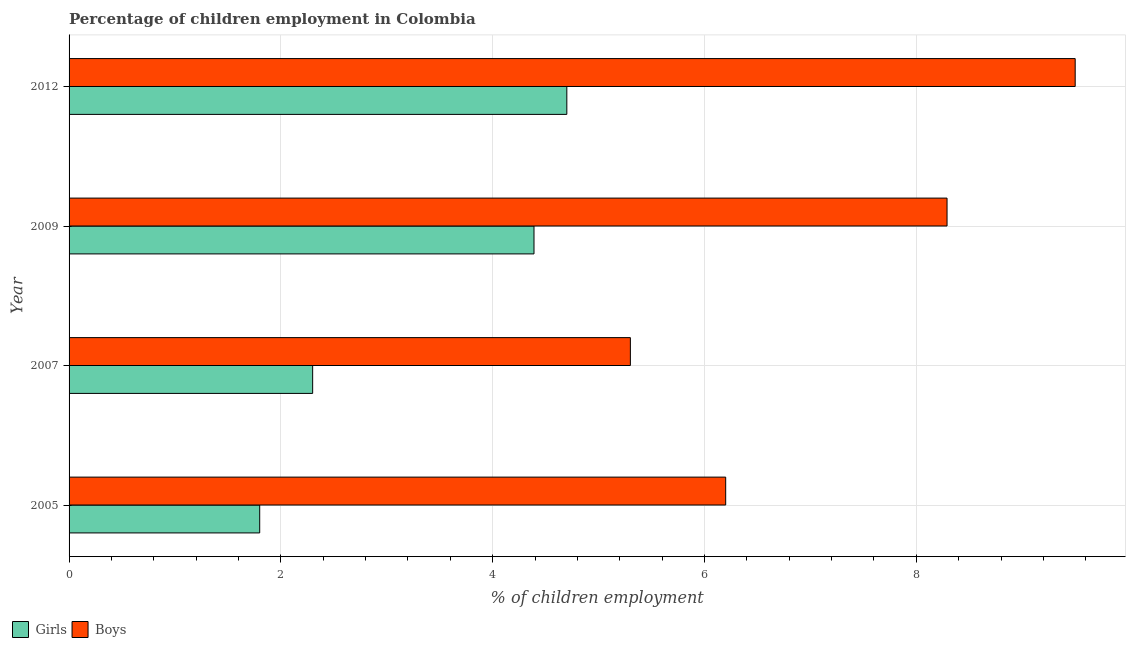How many different coloured bars are there?
Keep it short and to the point. 2. Are the number of bars on each tick of the Y-axis equal?
Your answer should be very brief. Yes. How many bars are there on the 2nd tick from the top?
Make the answer very short. 2. How many bars are there on the 3rd tick from the bottom?
Offer a terse response. 2. What is the label of the 1st group of bars from the top?
Keep it short and to the point. 2012. In how many cases, is the number of bars for a given year not equal to the number of legend labels?
Offer a terse response. 0. Across all years, what is the maximum percentage of employed girls?
Provide a succinct answer. 4.7. Across all years, what is the minimum percentage of employed boys?
Offer a terse response. 5.3. In which year was the percentage of employed boys minimum?
Make the answer very short. 2007. What is the total percentage of employed boys in the graph?
Ensure brevity in your answer.  29.29. What is the difference between the percentage of employed girls in 2005 and that in 2007?
Give a very brief answer. -0.5. What is the difference between the percentage of employed boys in 2009 and the percentage of employed girls in 2005?
Your answer should be very brief. 6.49. What is the average percentage of employed boys per year?
Your answer should be very brief. 7.32. In the year 2007, what is the difference between the percentage of employed boys and percentage of employed girls?
Ensure brevity in your answer.  3. What is the ratio of the percentage of employed girls in 2005 to that in 2009?
Give a very brief answer. 0.41. Is the difference between the percentage of employed boys in 2009 and 2012 greater than the difference between the percentage of employed girls in 2009 and 2012?
Provide a succinct answer. No. What is the difference between the highest and the second highest percentage of employed girls?
Your response must be concise. 0.31. Is the sum of the percentage of employed boys in 2005 and 2007 greater than the maximum percentage of employed girls across all years?
Offer a very short reply. Yes. What does the 2nd bar from the top in 2009 represents?
Provide a succinct answer. Girls. What does the 2nd bar from the bottom in 2007 represents?
Offer a terse response. Boys. How many years are there in the graph?
Your answer should be compact. 4. Are the values on the major ticks of X-axis written in scientific E-notation?
Your response must be concise. No. Does the graph contain any zero values?
Make the answer very short. No. Does the graph contain grids?
Provide a succinct answer. Yes. How are the legend labels stacked?
Ensure brevity in your answer.  Horizontal. What is the title of the graph?
Make the answer very short. Percentage of children employment in Colombia. Does "GDP per capita" appear as one of the legend labels in the graph?
Your answer should be very brief. No. What is the label or title of the X-axis?
Keep it short and to the point. % of children employment. What is the label or title of the Y-axis?
Give a very brief answer. Year. What is the % of children employment of Girls in 2005?
Offer a terse response. 1.8. What is the % of children employment in Boys in 2005?
Give a very brief answer. 6.2. What is the % of children employment in Boys in 2007?
Give a very brief answer. 5.3. What is the % of children employment of Girls in 2009?
Your answer should be compact. 4.39. What is the % of children employment of Boys in 2009?
Provide a succinct answer. 8.29. What is the % of children employment in Boys in 2012?
Your response must be concise. 9.5. Across all years, what is the minimum % of children employment of Girls?
Provide a succinct answer. 1.8. Across all years, what is the minimum % of children employment in Boys?
Keep it short and to the point. 5.3. What is the total % of children employment in Girls in the graph?
Ensure brevity in your answer.  13.19. What is the total % of children employment of Boys in the graph?
Provide a short and direct response. 29.29. What is the difference between the % of children employment in Girls in 2005 and that in 2009?
Give a very brief answer. -2.59. What is the difference between the % of children employment of Boys in 2005 and that in 2009?
Offer a very short reply. -2.09. What is the difference between the % of children employment in Girls in 2005 and that in 2012?
Give a very brief answer. -2.9. What is the difference between the % of children employment of Boys in 2005 and that in 2012?
Give a very brief answer. -3.3. What is the difference between the % of children employment in Girls in 2007 and that in 2009?
Make the answer very short. -2.09. What is the difference between the % of children employment of Boys in 2007 and that in 2009?
Give a very brief answer. -2.99. What is the difference between the % of children employment in Boys in 2007 and that in 2012?
Provide a succinct answer. -4.2. What is the difference between the % of children employment of Girls in 2009 and that in 2012?
Provide a short and direct response. -0.31. What is the difference between the % of children employment in Boys in 2009 and that in 2012?
Provide a succinct answer. -1.21. What is the difference between the % of children employment of Girls in 2005 and the % of children employment of Boys in 2007?
Provide a succinct answer. -3.5. What is the difference between the % of children employment of Girls in 2005 and the % of children employment of Boys in 2009?
Make the answer very short. -6.49. What is the difference between the % of children employment of Girls in 2007 and the % of children employment of Boys in 2009?
Offer a very short reply. -5.99. What is the difference between the % of children employment in Girls in 2009 and the % of children employment in Boys in 2012?
Provide a succinct answer. -5.11. What is the average % of children employment in Girls per year?
Keep it short and to the point. 3.3. What is the average % of children employment in Boys per year?
Your answer should be very brief. 7.32. In the year 2009, what is the difference between the % of children employment in Girls and % of children employment in Boys?
Provide a succinct answer. -3.9. What is the ratio of the % of children employment of Girls in 2005 to that in 2007?
Offer a very short reply. 0.78. What is the ratio of the % of children employment of Boys in 2005 to that in 2007?
Offer a terse response. 1.17. What is the ratio of the % of children employment in Girls in 2005 to that in 2009?
Your answer should be compact. 0.41. What is the ratio of the % of children employment in Boys in 2005 to that in 2009?
Your answer should be very brief. 0.75. What is the ratio of the % of children employment of Girls in 2005 to that in 2012?
Offer a very short reply. 0.38. What is the ratio of the % of children employment of Boys in 2005 to that in 2012?
Provide a succinct answer. 0.65. What is the ratio of the % of children employment of Girls in 2007 to that in 2009?
Make the answer very short. 0.52. What is the ratio of the % of children employment in Boys in 2007 to that in 2009?
Make the answer very short. 0.64. What is the ratio of the % of children employment in Girls in 2007 to that in 2012?
Provide a succinct answer. 0.49. What is the ratio of the % of children employment of Boys in 2007 to that in 2012?
Make the answer very short. 0.56. What is the ratio of the % of children employment in Girls in 2009 to that in 2012?
Offer a very short reply. 0.93. What is the ratio of the % of children employment of Boys in 2009 to that in 2012?
Ensure brevity in your answer.  0.87. What is the difference between the highest and the second highest % of children employment of Girls?
Make the answer very short. 0.31. What is the difference between the highest and the second highest % of children employment in Boys?
Your answer should be compact. 1.21. What is the difference between the highest and the lowest % of children employment in Girls?
Keep it short and to the point. 2.9. What is the difference between the highest and the lowest % of children employment of Boys?
Provide a succinct answer. 4.2. 